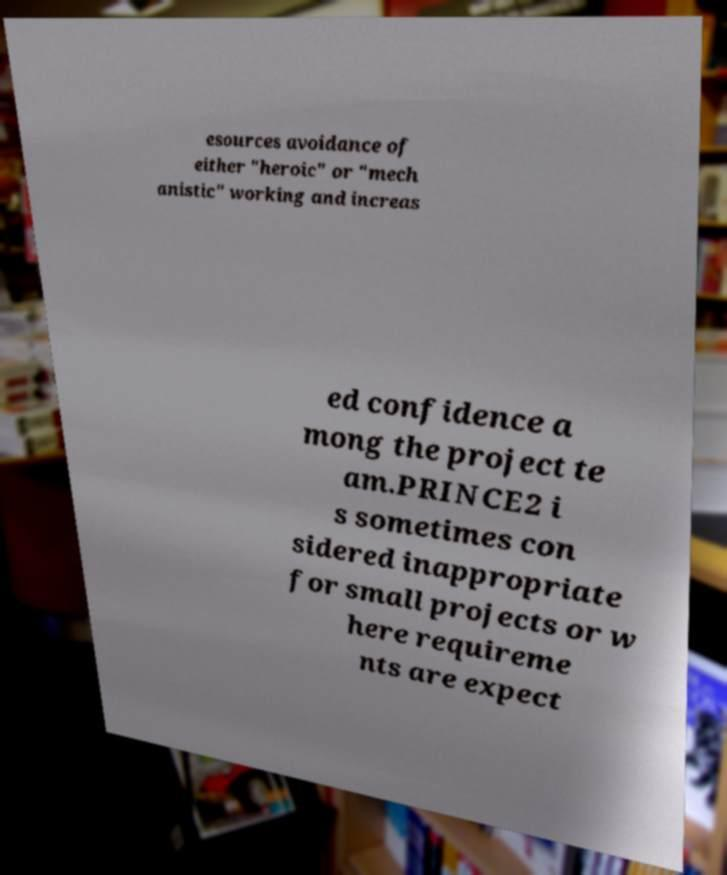Could you extract and type out the text from this image? esources avoidance of either "heroic" or "mech anistic" working and increas ed confidence a mong the project te am.PRINCE2 i s sometimes con sidered inappropriate for small projects or w here requireme nts are expect 